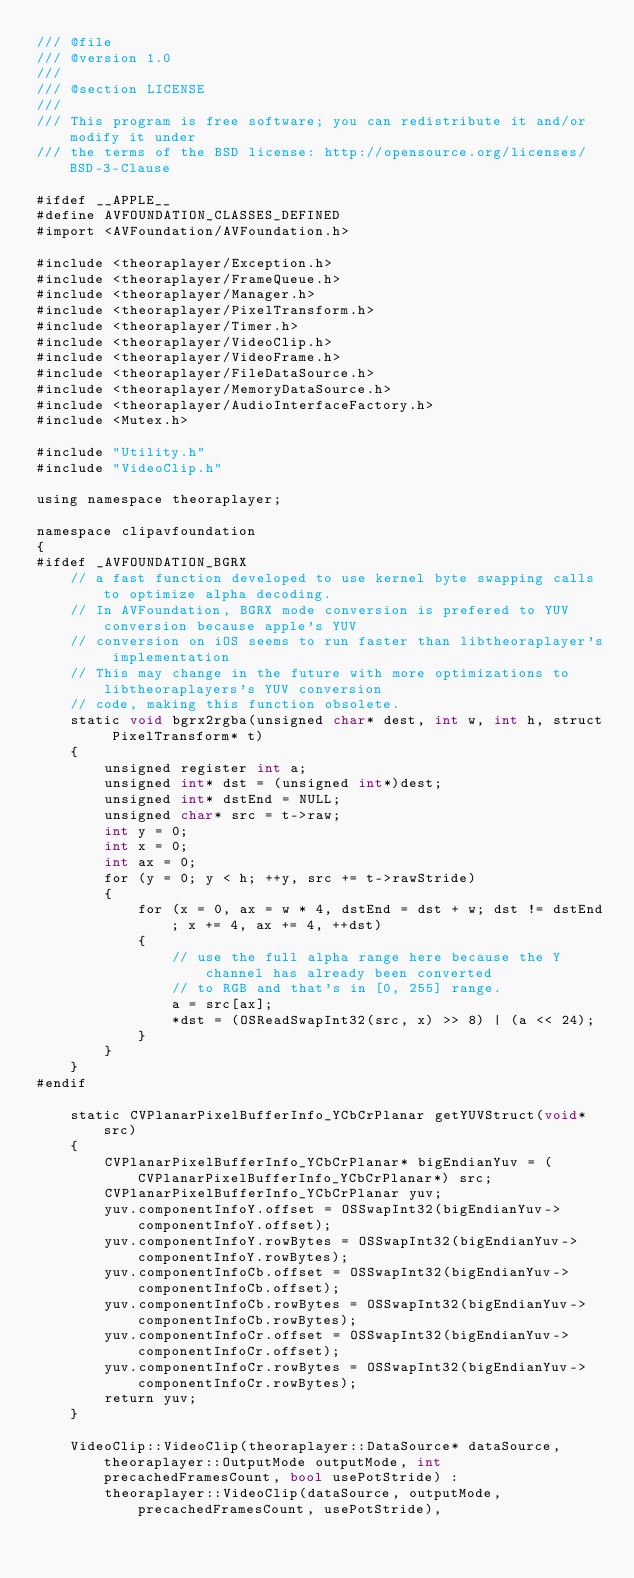Convert code to text. <code><loc_0><loc_0><loc_500><loc_500><_ObjectiveC_>/// @file
/// @version 1.0
/// 
/// @section LICENSE
/// 
/// This program is free software; you can redistribute it and/or modify it under
/// the terms of the BSD license: http://opensource.org/licenses/BSD-3-Clause

#ifdef __APPLE__
#define AVFOUNDATION_CLASSES_DEFINED
#import <AVFoundation/AVFoundation.h>

#include <theoraplayer/Exception.h>
#include <theoraplayer/FrameQueue.h>
#include <theoraplayer/Manager.h>
#include <theoraplayer/PixelTransform.h>
#include <theoraplayer/Timer.h>
#include <theoraplayer/VideoClip.h>
#include <theoraplayer/VideoFrame.h>
#include <theoraplayer/FileDataSource.h>
#include <theoraplayer/MemoryDataSource.h>
#include <theoraplayer/AudioInterfaceFactory.h>
#include <Mutex.h>

#include "Utility.h"
#include "VideoClip.h"

using namespace theoraplayer;

namespace clipavfoundation
{
#ifdef _AVFOUNDATION_BGRX
	// a fast function developed to use kernel byte swapping calls to optimize alpha decoding.
	// In AVFoundation, BGRX mode conversion is prefered to YUV conversion because apple's YUV
	// conversion on iOS seems to run faster than libtheoraplayer's implementation
	// This may change in the future with more optimizations to libtheoraplayers's YUV conversion
	// code, making this function obsolete.
	static void bgrx2rgba(unsigned char* dest, int w, int h, struct PixelTransform* t)
	{
		unsigned register int a;
		unsigned int* dst = (unsigned int*)dest;
		unsigned int* dstEnd = NULL;
		unsigned char* src = t->raw;
		int y = 0;
		int x = 0;
		int ax = 0;
		for (y = 0; y < h; ++y, src += t->rawStride)
		{
			for (x = 0, ax = w * 4, dstEnd = dst + w; dst != dstEnd; x += 4, ax += 4, ++dst)
			{
				// use the full alpha range here because the Y channel has already been converted
				// to RGB and that's in [0, 255] range.
				a = src[ax];
				*dst = (OSReadSwapInt32(src, x) >> 8) | (a << 24);
			}
		}
	}
#endif

	static CVPlanarPixelBufferInfo_YCbCrPlanar getYUVStruct(void* src)
	{
		CVPlanarPixelBufferInfo_YCbCrPlanar* bigEndianYuv = (CVPlanarPixelBufferInfo_YCbCrPlanar*) src;
		CVPlanarPixelBufferInfo_YCbCrPlanar yuv;
		yuv.componentInfoY.offset = OSSwapInt32(bigEndianYuv->componentInfoY.offset);
		yuv.componentInfoY.rowBytes = OSSwapInt32(bigEndianYuv->componentInfoY.rowBytes);
		yuv.componentInfoCb.offset = OSSwapInt32(bigEndianYuv->componentInfoCb.offset);
		yuv.componentInfoCb.rowBytes = OSSwapInt32(bigEndianYuv->componentInfoCb.rowBytes);
		yuv.componentInfoCr.offset = OSSwapInt32(bigEndianYuv->componentInfoCr.offset);
		yuv.componentInfoCr.rowBytes = OSSwapInt32(bigEndianYuv->componentInfoCr.rowBytes);
		return yuv;
	}
	
	VideoClip::VideoClip(theoraplayer::DataSource* dataSource, theoraplayer::OutputMode outputMode, int precachedFramesCount, bool usePotStride) :
		theoraplayer::VideoClip(dataSource, outputMode, precachedFramesCount, usePotStride),</code> 